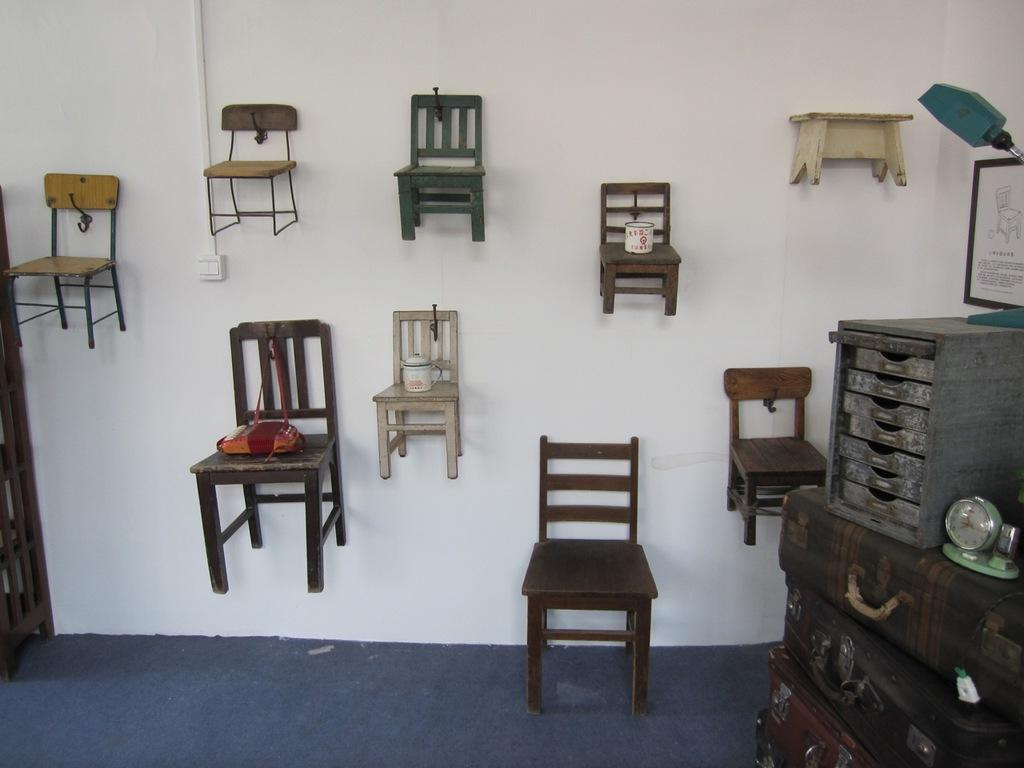What type of furniture is present in the image? There are chairs and a table in the image. What additional items can be seen in the image? There are trunk boxes, a clock, a picture, a lamp, and a carpet in the image. Are there any objects on the wall? Yes, a table, chairs, and a picture are on the wall. What type of flooring is visible in the image? The carpet in the image suggests that there is carpeted flooring. Can you describe the creature that is weaving thread on the carpet in the image? There is no creature present in the image, nor is there any thread being woven on the carpet. 